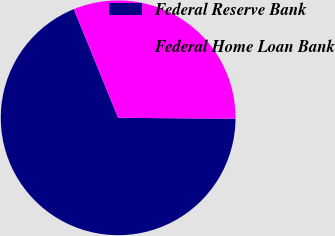Convert chart to OTSL. <chart><loc_0><loc_0><loc_500><loc_500><pie_chart><fcel>Federal Reserve Bank<fcel>Federal Home Loan Bank<nl><fcel>68.71%<fcel>31.29%<nl></chart> 